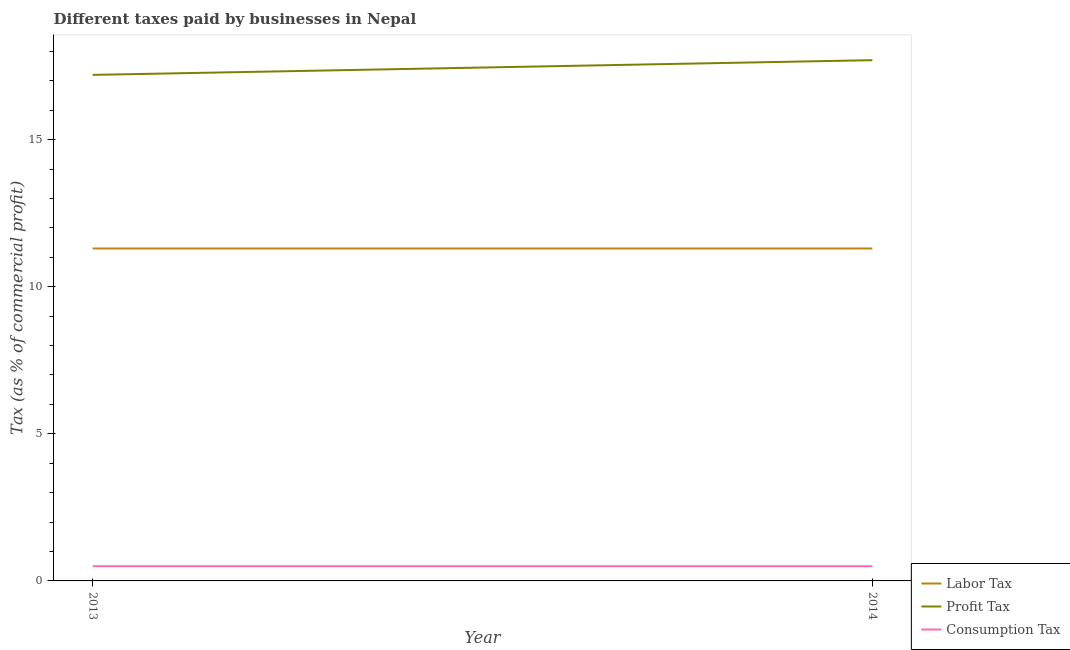How many different coloured lines are there?
Your response must be concise. 3. Does the line corresponding to percentage of profit tax intersect with the line corresponding to percentage of labor tax?
Offer a terse response. No. Is the number of lines equal to the number of legend labels?
Your answer should be very brief. Yes. Across all years, what is the maximum percentage of profit tax?
Your answer should be compact. 17.7. In which year was the percentage of profit tax minimum?
Make the answer very short. 2013. What is the total percentage of profit tax in the graph?
Provide a succinct answer. 34.9. What is the difference between the percentage of labor tax in 2013 and that in 2014?
Provide a succinct answer. 0. In the year 2013, what is the difference between the percentage of labor tax and percentage of profit tax?
Keep it short and to the point. -5.9. In how many years, is the percentage of consumption tax greater than 5 %?
Your answer should be compact. 0. Is the percentage of labor tax in 2013 less than that in 2014?
Your answer should be compact. No. Is it the case that in every year, the sum of the percentage of labor tax and percentage of profit tax is greater than the percentage of consumption tax?
Ensure brevity in your answer.  Yes. Is the percentage of labor tax strictly greater than the percentage of consumption tax over the years?
Ensure brevity in your answer.  Yes. How many lines are there?
Give a very brief answer. 3. Where does the legend appear in the graph?
Provide a short and direct response. Bottom right. How many legend labels are there?
Your response must be concise. 3. How are the legend labels stacked?
Provide a succinct answer. Vertical. What is the title of the graph?
Provide a succinct answer. Different taxes paid by businesses in Nepal. Does "Taxes on international trade" appear as one of the legend labels in the graph?
Keep it short and to the point. No. What is the label or title of the Y-axis?
Make the answer very short. Tax (as % of commercial profit). What is the Tax (as % of commercial profit) in Consumption Tax in 2014?
Provide a succinct answer. 0.5. Across all years, what is the maximum Tax (as % of commercial profit) of Consumption Tax?
Ensure brevity in your answer.  0.5. What is the total Tax (as % of commercial profit) of Labor Tax in the graph?
Provide a short and direct response. 22.6. What is the total Tax (as % of commercial profit) of Profit Tax in the graph?
Offer a very short reply. 34.9. What is the total Tax (as % of commercial profit) of Consumption Tax in the graph?
Provide a short and direct response. 1. What is the difference between the Tax (as % of commercial profit) of Labor Tax in 2013 and that in 2014?
Ensure brevity in your answer.  0. What is the difference between the Tax (as % of commercial profit) in Profit Tax in 2013 and that in 2014?
Your answer should be very brief. -0.5. What is the difference between the Tax (as % of commercial profit) of Consumption Tax in 2013 and that in 2014?
Make the answer very short. 0. What is the difference between the Tax (as % of commercial profit) of Labor Tax in 2013 and the Tax (as % of commercial profit) of Profit Tax in 2014?
Keep it short and to the point. -6.4. What is the difference between the Tax (as % of commercial profit) in Profit Tax in 2013 and the Tax (as % of commercial profit) in Consumption Tax in 2014?
Give a very brief answer. 16.7. What is the average Tax (as % of commercial profit) in Labor Tax per year?
Your answer should be compact. 11.3. What is the average Tax (as % of commercial profit) of Profit Tax per year?
Your answer should be compact. 17.45. In the year 2013, what is the difference between the Tax (as % of commercial profit) in Labor Tax and Tax (as % of commercial profit) in Consumption Tax?
Make the answer very short. 10.8. In the year 2013, what is the difference between the Tax (as % of commercial profit) in Profit Tax and Tax (as % of commercial profit) in Consumption Tax?
Make the answer very short. 16.7. In the year 2014, what is the difference between the Tax (as % of commercial profit) of Labor Tax and Tax (as % of commercial profit) of Profit Tax?
Ensure brevity in your answer.  -6.4. In the year 2014, what is the difference between the Tax (as % of commercial profit) in Labor Tax and Tax (as % of commercial profit) in Consumption Tax?
Your answer should be compact. 10.8. In the year 2014, what is the difference between the Tax (as % of commercial profit) of Profit Tax and Tax (as % of commercial profit) of Consumption Tax?
Your answer should be compact. 17.2. What is the ratio of the Tax (as % of commercial profit) in Profit Tax in 2013 to that in 2014?
Offer a terse response. 0.97. What is the difference between the highest and the second highest Tax (as % of commercial profit) of Labor Tax?
Your response must be concise. 0. What is the difference between the highest and the lowest Tax (as % of commercial profit) in Labor Tax?
Provide a short and direct response. 0. What is the difference between the highest and the lowest Tax (as % of commercial profit) of Consumption Tax?
Give a very brief answer. 0. 